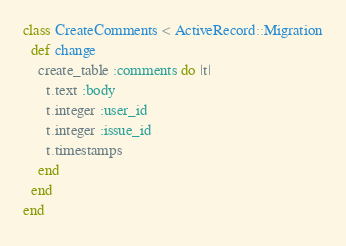<code> <loc_0><loc_0><loc_500><loc_500><_Ruby_>class CreateComments < ActiveRecord::Migration
  def change
    create_table :comments do |t|
      t.text :body
      t.integer :user_id
      t.integer :issue_id
      t.timestamps
    end
  end
end</code> 